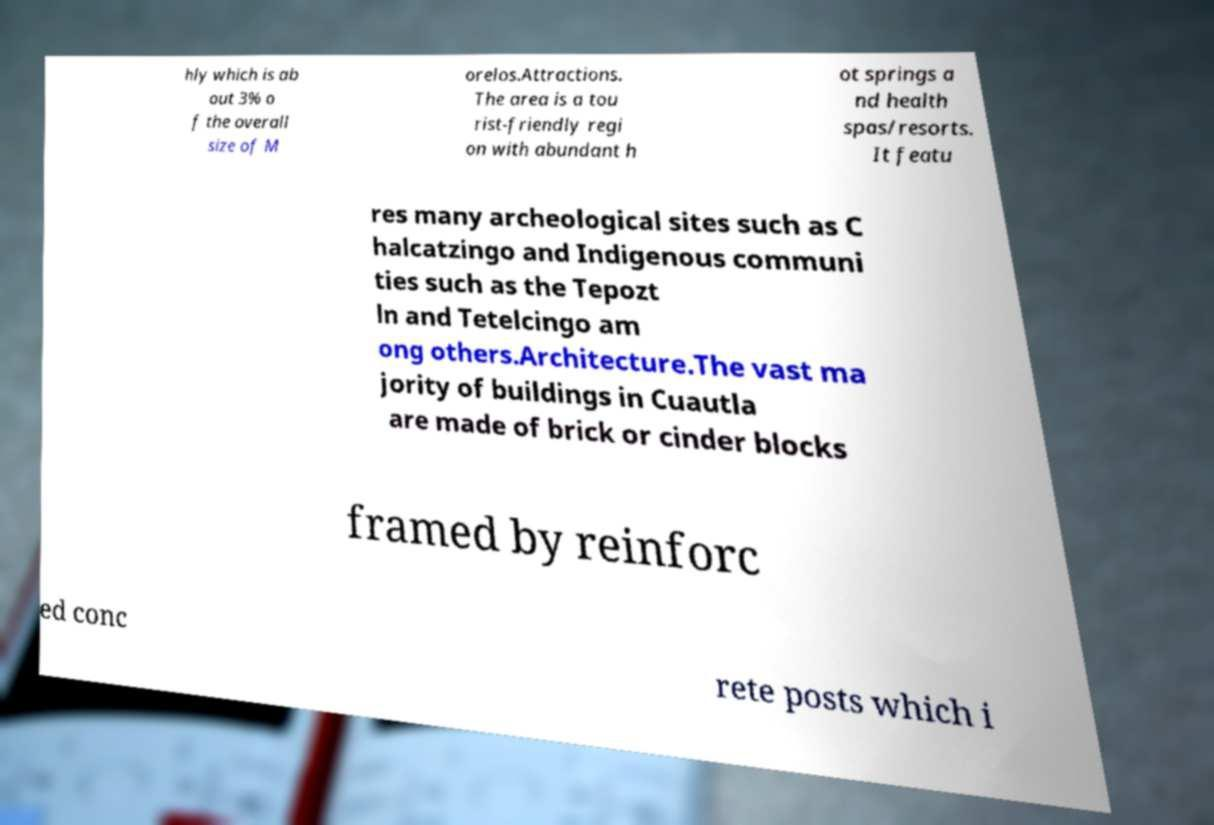There's text embedded in this image that I need extracted. Can you transcribe it verbatim? hly which is ab out 3% o f the overall size of M orelos.Attractions. The area is a tou rist-friendly regi on with abundant h ot springs a nd health spas/resorts. It featu res many archeological sites such as C halcatzingo and Indigenous communi ties such as the Tepozt ln and Tetelcingo am ong others.Architecture.The vast ma jority of buildings in Cuautla are made of brick or cinder blocks framed by reinforc ed conc rete posts which i 